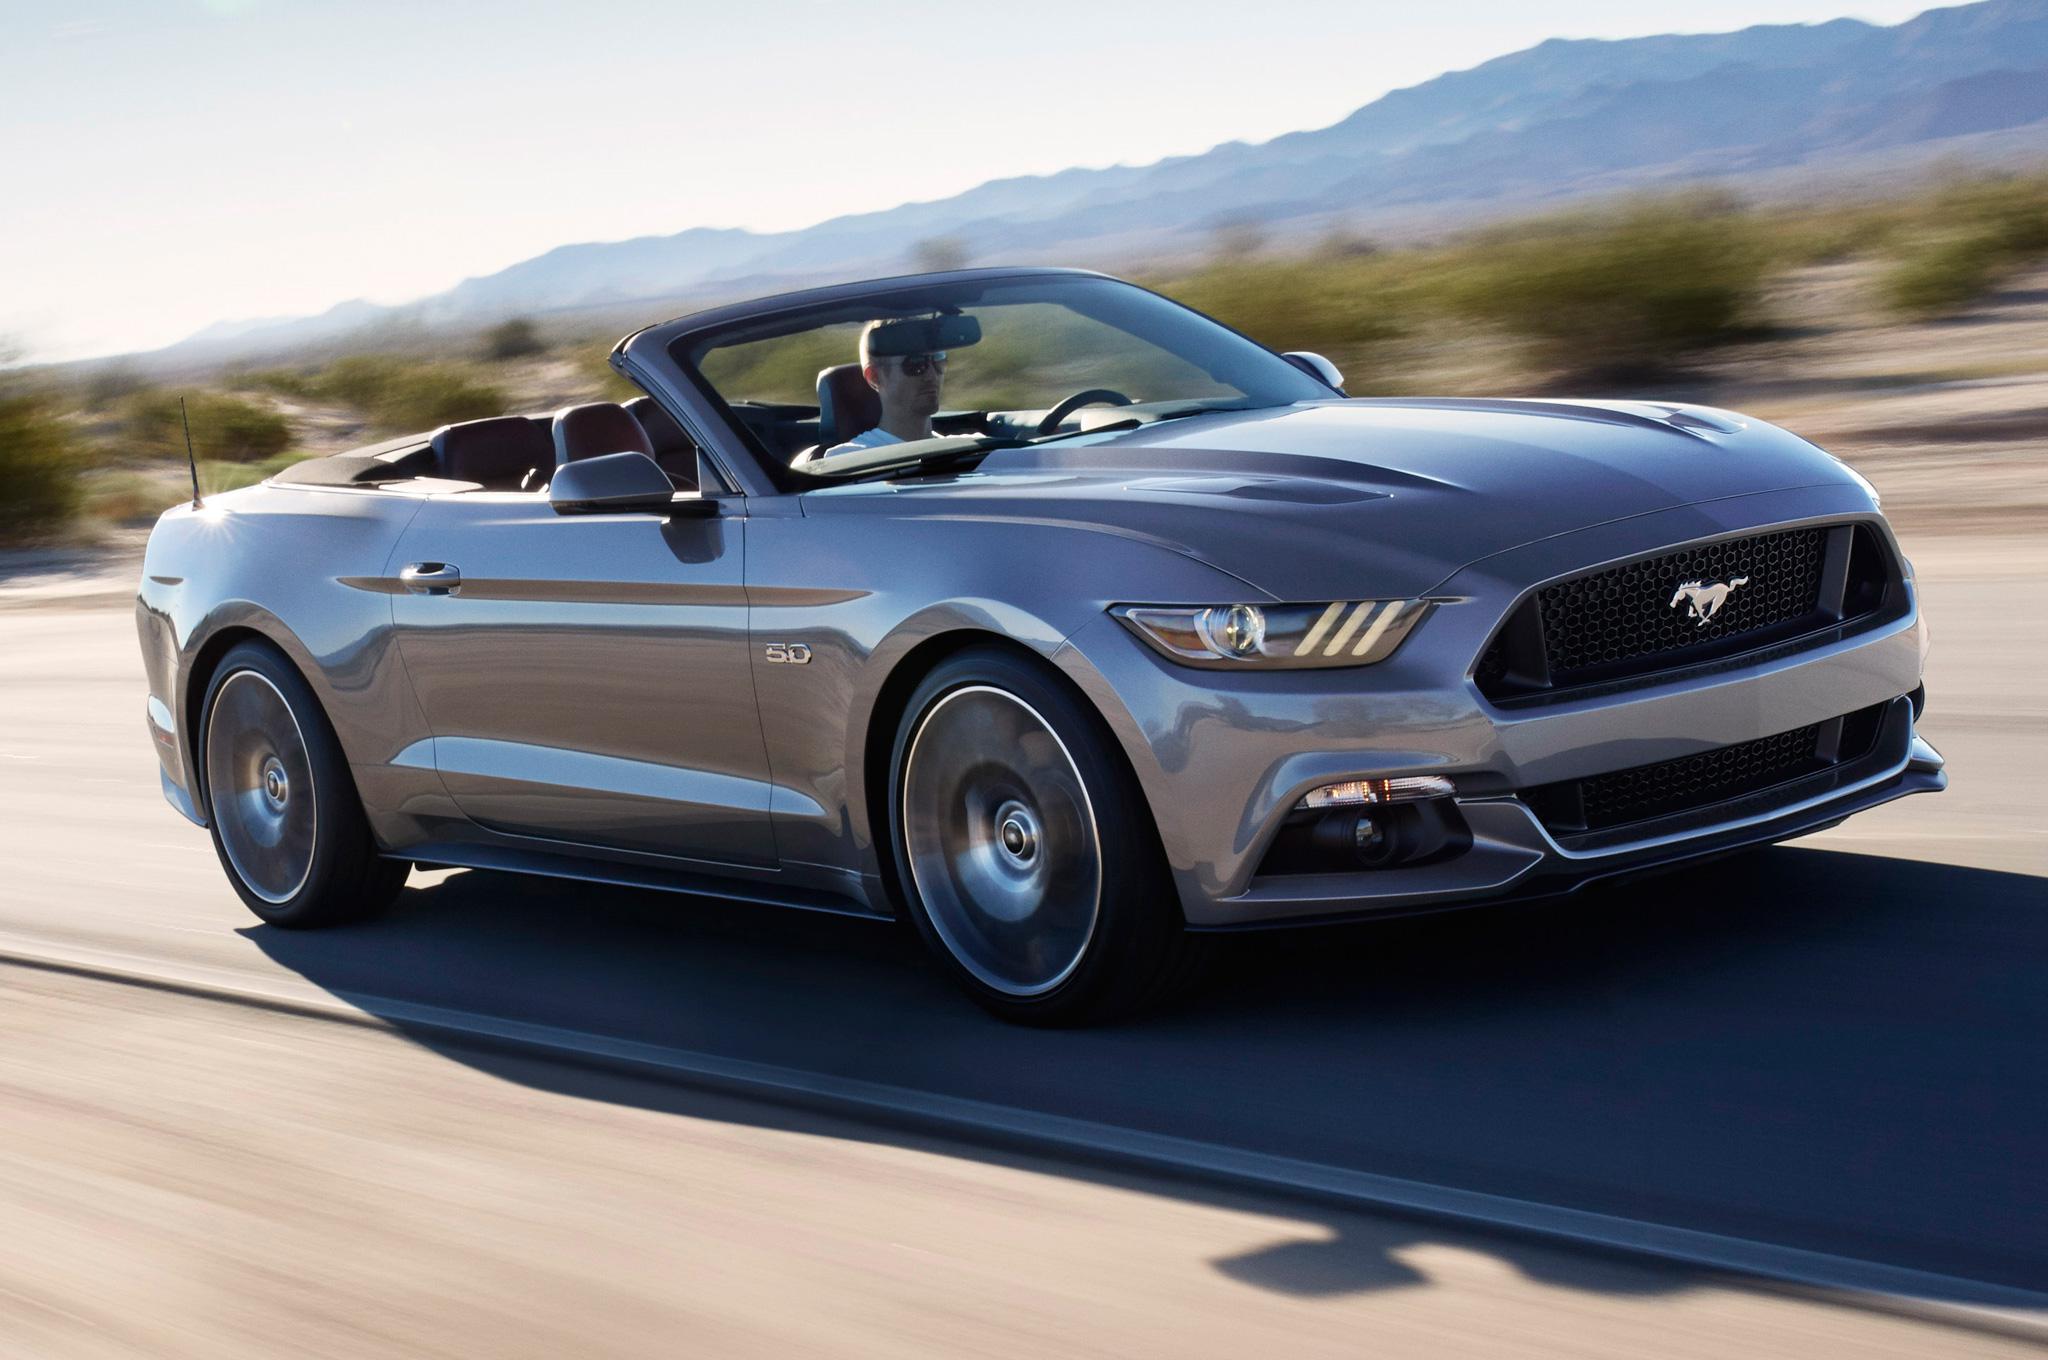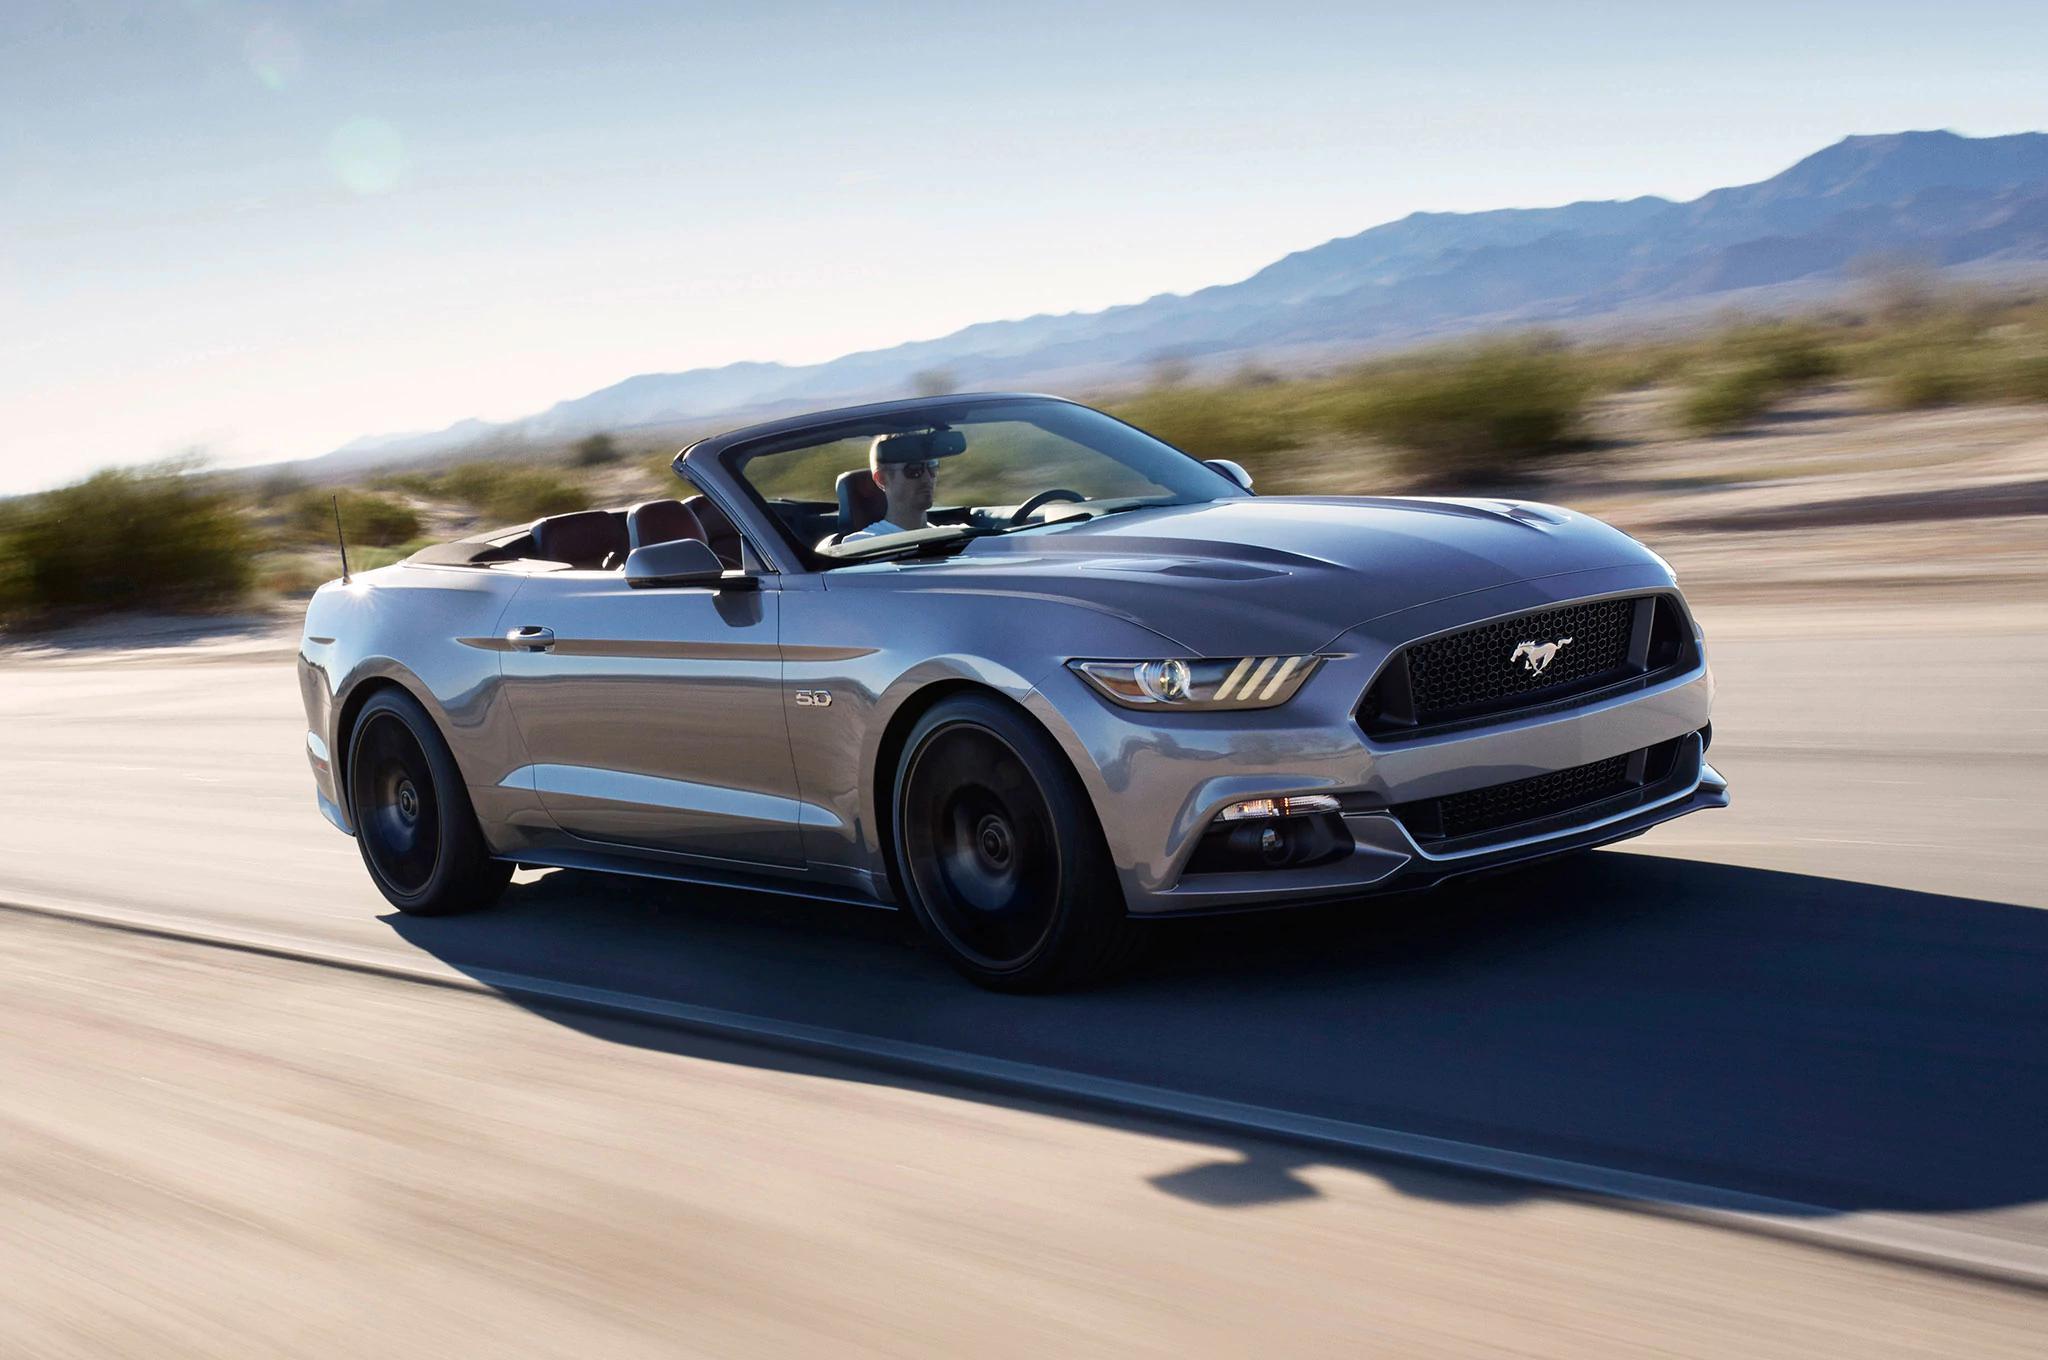The first image is the image on the left, the second image is the image on the right. For the images shown, is this caption "A red convertible with the top down is shown in the left image on a paved surface" true? Answer yes or no. No. The first image is the image on the left, the second image is the image on the right. Analyze the images presented: Is the assertion "A red convertible is displayed at an angle on pavement in the left image, while the right image shows a white convertible." valid? Answer yes or no. No. 